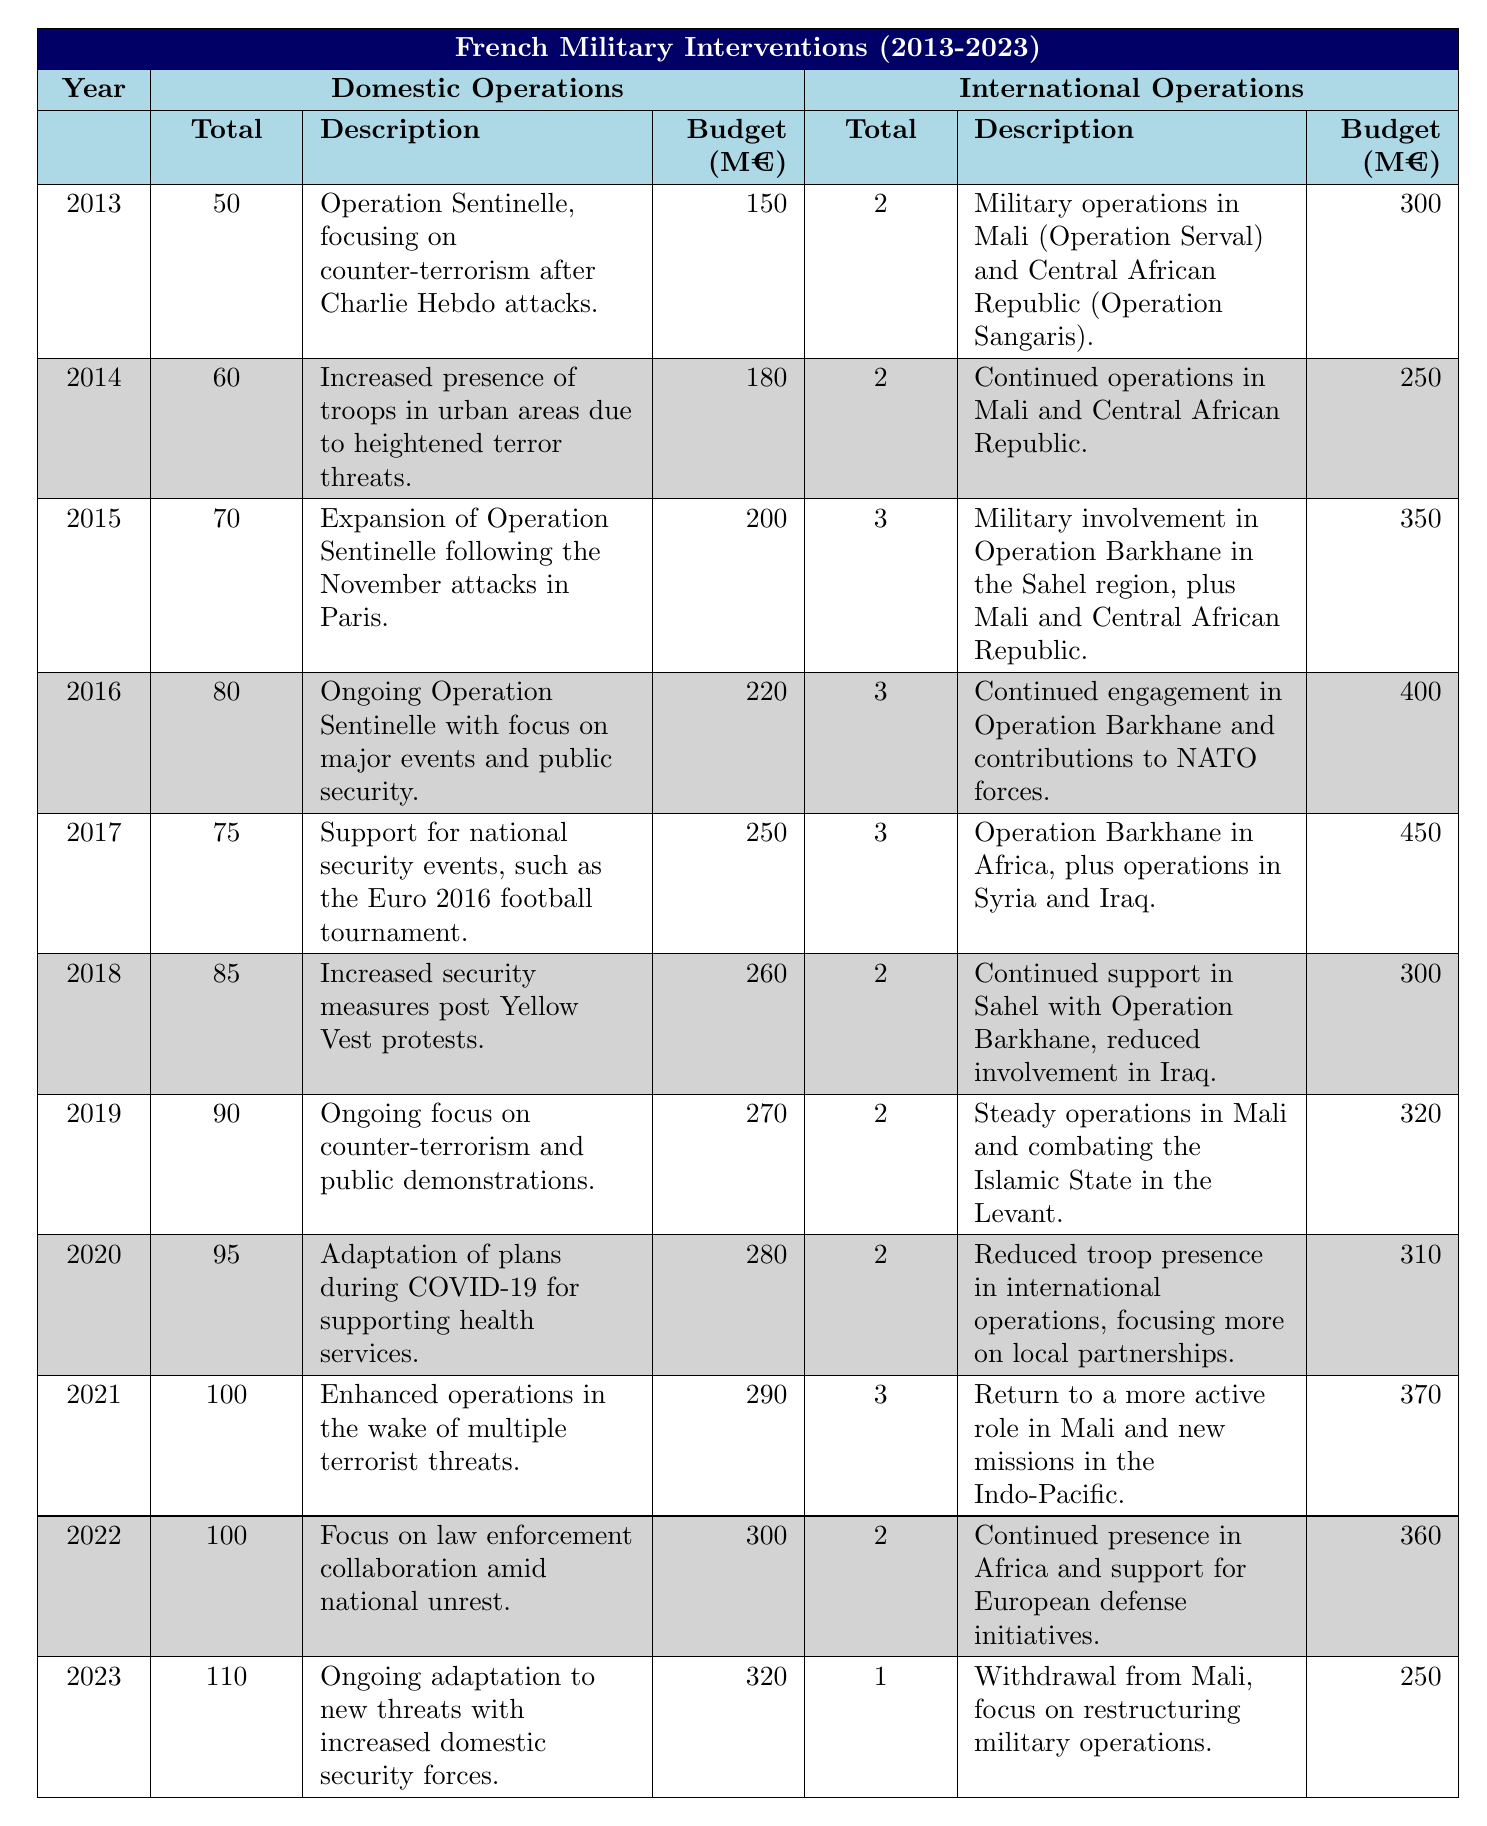What was the total budget for domestic operations in 2015? The budget for domestic operations in 2015 is directly given in the table, which states it was 200 million euros.
Answer: 200 million euros How many international operations were conducted in 2022? The total count of international operations for 2022 is found in the respective column of the table, where it shows that there were 2 operations that year.
Answer: 2 What is the average budget for domestic operations over the past decade (2013-2023)? First, we sum the budgets for each year from the domestic operations: 150 + 180 + 200 + 220 + 250 + 260 + 270 + 280 + 290 + 300 + 320 = 2450 million euros. Then, we divide by 11 (the number of years) to get the average: 2450 / 11 ≈ 222.73 million euros.
Answer: Approximately 222.73 million euros Was there an increase in the total number of domestic operations from 2013 to 2023? The number of domestic operations in 2013 was 50 and in 2023 it was 110. Since 110 is greater than 50, this indicates an increase.
Answer: Yes What was the percentage change in the budget for international operations from 2018 to 2019? The budget for international operations in 2018 was 300 million euros and in 2019 it was 320 million euros. The difference is 320 - 300 = 20 million euros. To find the percentage change: (20 / 300) * 100 = 6.67%.
Answer: 6.67% In which year did France spend the most on domestic operations? By reviewing the domestic budget figures from the table, we see that the highest budget was in 2023, with 320 million euros allocated for domestic operations.
Answer: 2023 Did France conduct more international operations in 2017 or 2019? The table indicates that there were 3 international operations in 2017 and 2 in 2019. Comparing these values: 3 (2017) > 2 (2019), thus 2017 had more operations.
Answer: 2017 What was the total military operation budget for France in 2021? The total budget consists of both domestic and international operations in 2021. Domestic budget was 290 million euros and international budget was 370 million euros. Therefore, the total budget is 290 + 370 = 660 million euros.
Answer: 660 million euros What trend can be seen in the number of domestic operations from 2013 to 2023? By examining the figures, the number of domestic operations increased every year from 50 in 2013 to 110 in 2023, indicating a consistent upward trend.
Answer: Increasing trend Which year had the most significant increase in the budget for domestic operations compared to the previous year? By examining the changes year by year: 2014 (180), 2015 (200) → increase of 20; 2015 (200), 2016 (220) → increase of 20; 2016 (220), 2017 (250) → increase of 30; ... The largest increase was from 2022 (300) to 2023 (320), which is an increase of 20.
Answer: 2021 to 2022 had the most significant increase of 30 million euros 